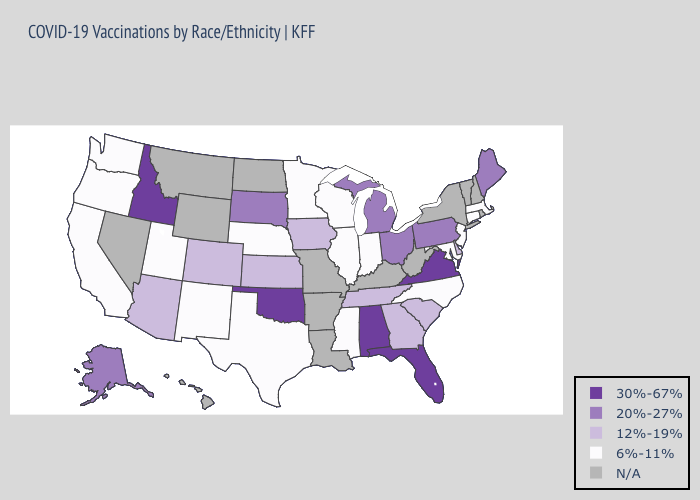What is the value of Oregon?
Write a very short answer. 6%-11%. Does Maryland have the lowest value in the South?
Concise answer only. Yes. Does Virginia have the highest value in the USA?
Give a very brief answer. Yes. Name the states that have a value in the range 6%-11%?
Answer briefly. California, Connecticut, Illinois, Indiana, Maryland, Massachusetts, Minnesota, Mississippi, Nebraska, New Jersey, New Mexico, North Carolina, Oregon, Texas, Utah, Washington, Wisconsin. What is the highest value in states that border Illinois?
Short answer required. 12%-19%. What is the value of Vermont?
Be succinct. N/A. How many symbols are there in the legend?
Concise answer only. 5. Name the states that have a value in the range 30%-67%?
Short answer required. Alabama, Florida, Idaho, Oklahoma, Virginia. Does Idaho have the highest value in the USA?
Give a very brief answer. Yes. Is the legend a continuous bar?
Give a very brief answer. No. Name the states that have a value in the range 30%-67%?
Answer briefly. Alabama, Florida, Idaho, Oklahoma, Virginia. Does the map have missing data?
Keep it brief. Yes. Name the states that have a value in the range N/A?
Keep it brief. Arkansas, Hawaii, Kentucky, Louisiana, Missouri, Montana, Nevada, New Hampshire, New York, North Dakota, Rhode Island, Vermont, West Virginia, Wyoming. What is the lowest value in the USA?
Short answer required. 6%-11%. 